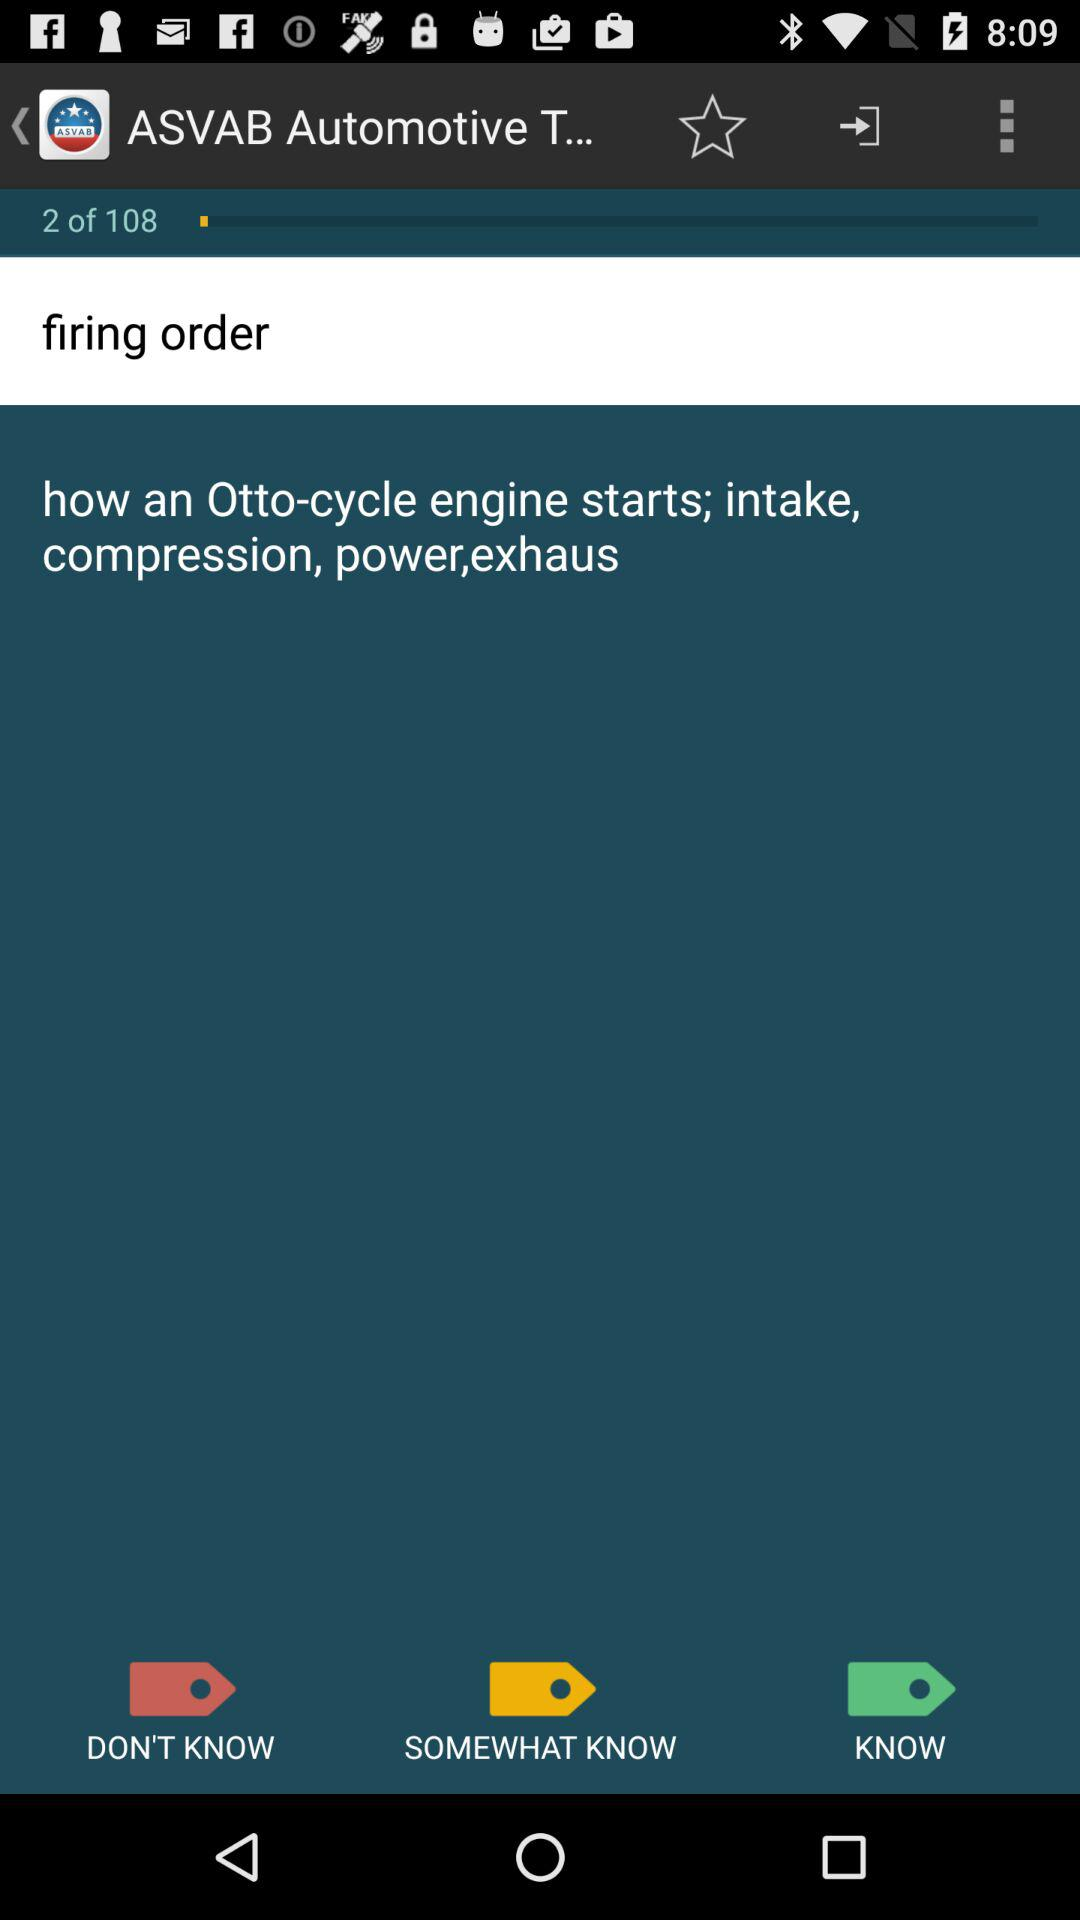How many total tags are there?
Answer the question using a single word or phrase. 3 